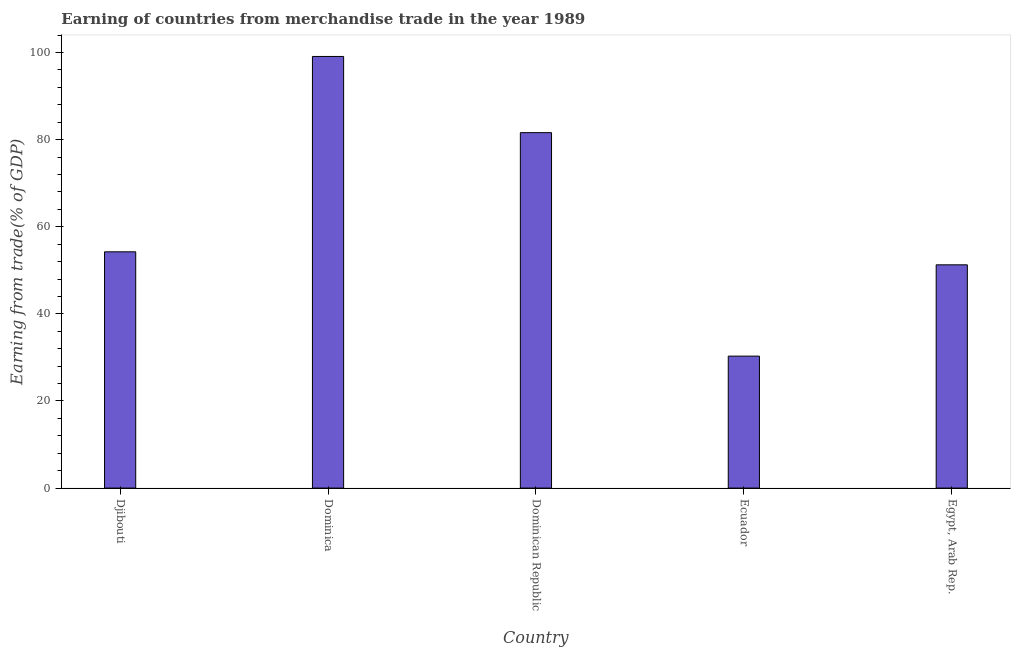What is the title of the graph?
Offer a very short reply. Earning of countries from merchandise trade in the year 1989. What is the label or title of the Y-axis?
Your answer should be very brief. Earning from trade(% of GDP). What is the earning from merchandise trade in Egypt, Arab Rep.?
Keep it short and to the point. 51.26. Across all countries, what is the maximum earning from merchandise trade?
Your answer should be very brief. 99.1. Across all countries, what is the minimum earning from merchandise trade?
Your answer should be compact. 30.3. In which country was the earning from merchandise trade maximum?
Offer a very short reply. Dominica. In which country was the earning from merchandise trade minimum?
Your response must be concise. Ecuador. What is the sum of the earning from merchandise trade?
Provide a short and direct response. 316.53. What is the difference between the earning from merchandise trade in Dominica and Dominican Republic?
Your answer should be compact. 17.49. What is the average earning from merchandise trade per country?
Provide a short and direct response. 63.31. What is the median earning from merchandise trade?
Ensure brevity in your answer.  54.25. What is the ratio of the earning from merchandise trade in Ecuador to that in Egypt, Arab Rep.?
Offer a very short reply. 0.59. What is the difference between the highest and the second highest earning from merchandise trade?
Make the answer very short. 17.49. What is the difference between the highest and the lowest earning from merchandise trade?
Offer a very short reply. 68.8. In how many countries, is the earning from merchandise trade greater than the average earning from merchandise trade taken over all countries?
Offer a very short reply. 2. How many countries are there in the graph?
Keep it short and to the point. 5. What is the difference between two consecutive major ticks on the Y-axis?
Your answer should be compact. 20. Are the values on the major ticks of Y-axis written in scientific E-notation?
Provide a short and direct response. No. What is the Earning from trade(% of GDP) in Djibouti?
Make the answer very short. 54.25. What is the Earning from trade(% of GDP) in Dominica?
Your response must be concise. 99.1. What is the Earning from trade(% of GDP) in Dominican Republic?
Ensure brevity in your answer.  81.61. What is the Earning from trade(% of GDP) in Ecuador?
Offer a terse response. 30.3. What is the Earning from trade(% of GDP) in Egypt, Arab Rep.?
Provide a succinct answer. 51.26. What is the difference between the Earning from trade(% of GDP) in Djibouti and Dominica?
Your response must be concise. -44.85. What is the difference between the Earning from trade(% of GDP) in Djibouti and Dominican Republic?
Give a very brief answer. -27.36. What is the difference between the Earning from trade(% of GDP) in Djibouti and Ecuador?
Ensure brevity in your answer.  23.95. What is the difference between the Earning from trade(% of GDP) in Djibouti and Egypt, Arab Rep.?
Give a very brief answer. 2.99. What is the difference between the Earning from trade(% of GDP) in Dominica and Dominican Republic?
Your answer should be compact. 17.49. What is the difference between the Earning from trade(% of GDP) in Dominica and Ecuador?
Your answer should be compact. 68.8. What is the difference between the Earning from trade(% of GDP) in Dominica and Egypt, Arab Rep.?
Offer a very short reply. 47.84. What is the difference between the Earning from trade(% of GDP) in Dominican Republic and Ecuador?
Make the answer very short. 51.31. What is the difference between the Earning from trade(% of GDP) in Dominican Republic and Egypt, Arab Rep.?
Your answer should be very brief. 30.35. What is the difference between the Earning from trade(% of GDP) in Ecuador and Egypt, Arab Rep.?
Give a very brief answer. -20.96. What is the ratio of the Earning from trade(% of GDP) in Djibouti to that in Dominica?
Offer a very short reply. 0.55. What is the ratio of the Earning from trade(% of GDP) in Djibouti to that in Dominican Republic?
Give a very brief answer. 0.67. What is the ratio of the Earning from trade(% of GDP) in Djibouti to that in Ecuador?
Offer a terse response. 1.79. What is the ratio of the Earning from trade(% of GDP) in Djibouti to that in Egypt, Arab Rep.?
Offer a terse response. 1.06. What is the ratio of the Earning from trade(% of GDP) in Dominica to that in Dominican Republic?
Keep it short and to the point. 1.21. What is the ratio of the Earning from trade(% of GDP) in Dominica to that in Ecuador?
Ensure brevity in your answer.  3.27. What is the ratio of the Earning from trade(% of GDP) in Dominica to that in Egypt, Arab Rep.?
Offer a very short reply. 1.93. What is the ratio of the Earning from trade(% of GDP) in Dominican Republic to that in Ecuador?
Your response must be concise. 2.69. What is the ratio of the Earning from trade(% of GDP) in Dominican Republic to that in Egypt, Arab Rep.?
Provide a succinct answer. 1.59. What is the ratio of the Earning from trade(% of GDP) in Ecuador to that in Egypt, Arab Rep.?
Offer a very short reply. 0.59. 